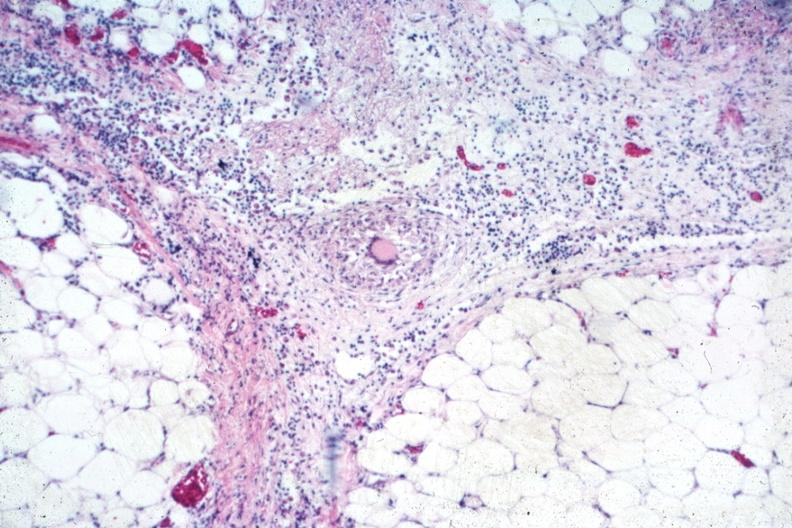what is present?
Answer the question using a single word or phrase. Peritoneum 